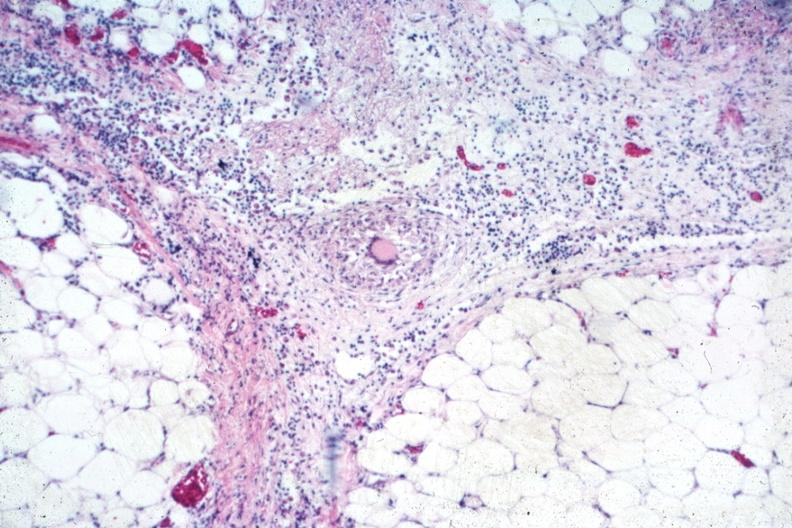what is present?
Answer the question using a single word or phrase. Peritoneum 